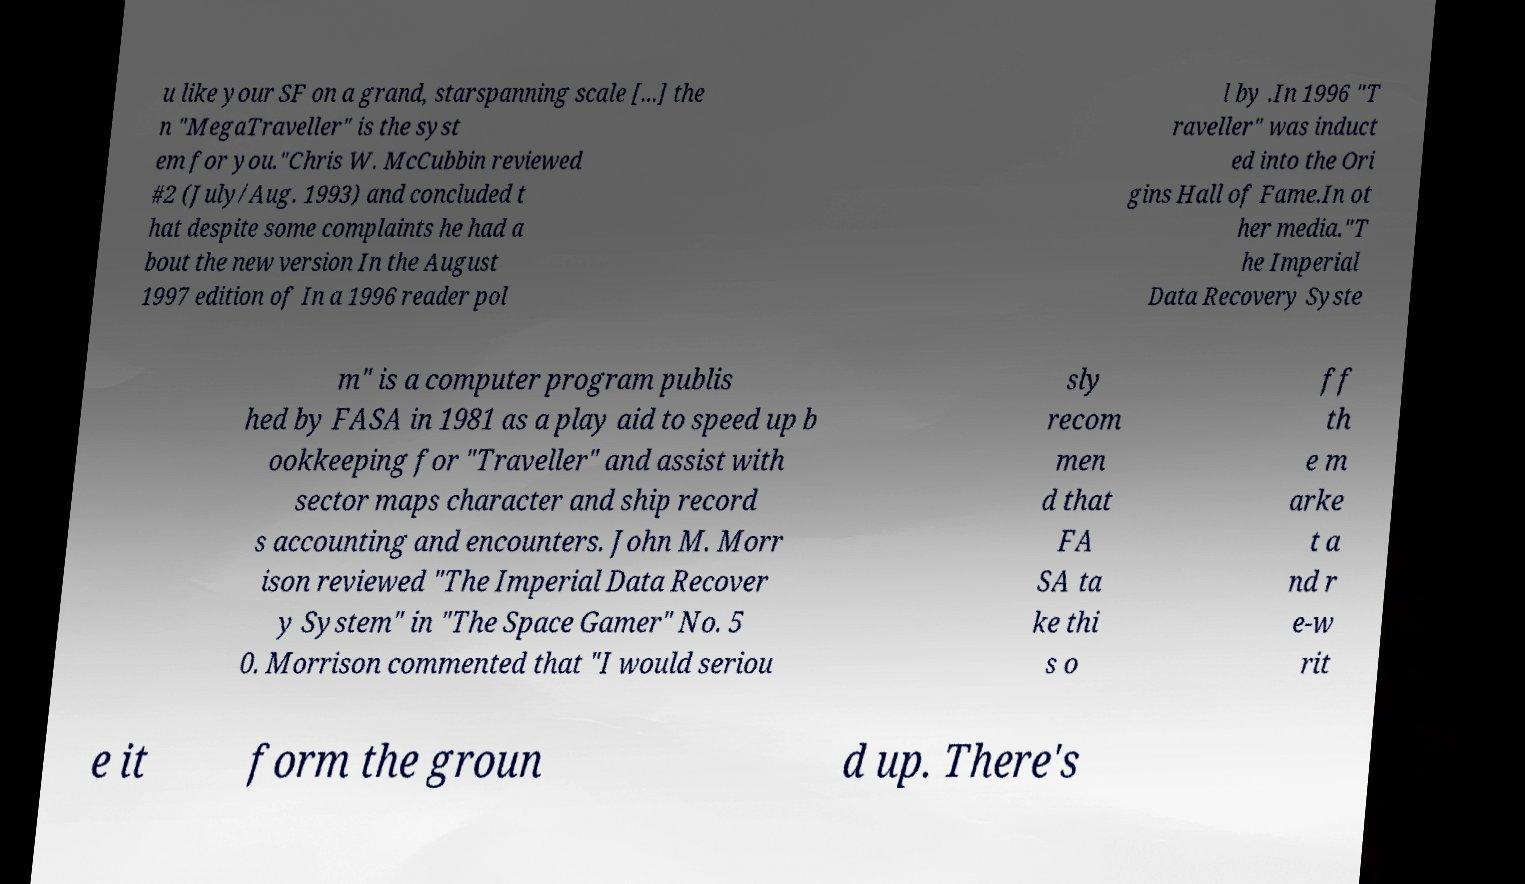I need the written content from this picture converted into text. Can you do that? u like your SF on a grand, starspanning scale [...] the n "MegaTraveller" is the syst em for you."Chris W. McCubbin reviewed #2 (July/Aug. 1993) and concluded t hat despite some complaints he had a bout the new version In the August 1997 edition of In a 1996 reader pol l by .In 1996 "T raveller" was induct ed into the Ori gins Hall of Fame.In ot her media."T he Imperial Data Recovery Syste m" is a computer program publis hed by FASA in 1981 as a play aid to speed up b ookkeeping for "Traveller" and assist with sector maps character and ship record s accounting and encounters. John M. Morr ison reviewed "The Imperial Data Recover y System" in "The Space Gamer" No. 5 0. Morrison commented that "I would seriou sly recom men d that FA SA ta ke thi s o ff th e m arke t a nd r e-w rit e it form the groun d up. There's 